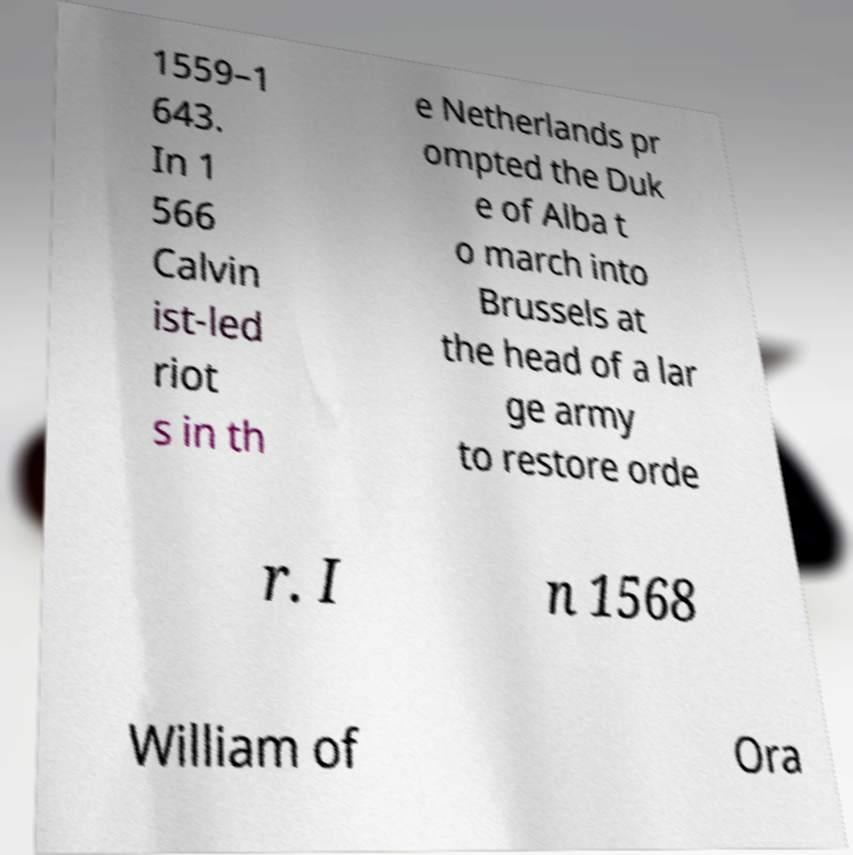Please read and relay the text visible in this image. What does it say? 1559–1 643. In 1 566 Calvin ist-led riot s in th e Netherlands pr ompted the Duk e of Alba t o march into Brussels at the head of a lar ge army to restore orde r. I n 1568 William of Ora 